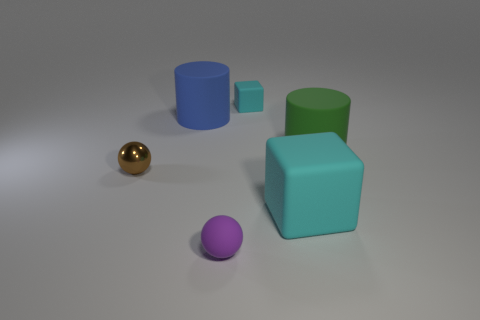Add 3 tiny green rubber blocks. How many objects exist? 9 Subtract all balls. How many objects are left? 4 Add 2 tiny cyan objects. How many tiny cyan objects are left? 3 Add 1 small cyan objects. How many small cyan objects exist? 2 Subtract 0 green balls. How many objects are left? 6 Subtract all small metallic objects. Subtract all small brown shiny objects. How many objects are left? 4 